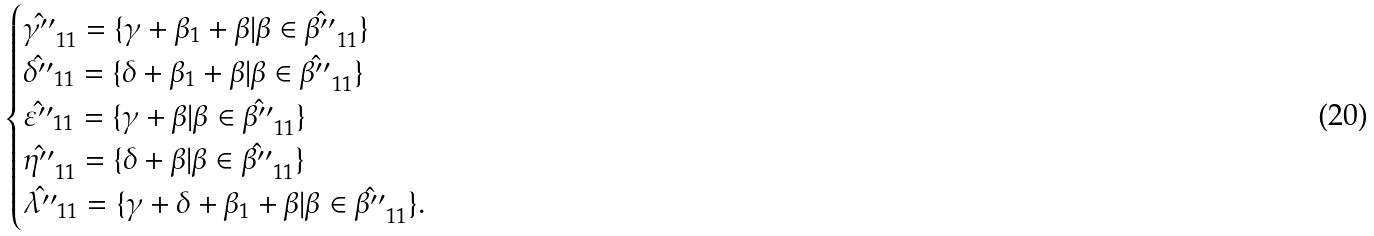Convert formula to latex. <formula><loc_0><loc_0><loc_500><loc_500>\begin{cases} \hat { \gamma ^ { \prime \prime } } _ { 1 1 } = \{ \gamma + \beta _ { 1 } + \beta | \beta \in \hat { \beta ^ { \prime \prime } } _ { 1 1 } \} \\ \hat { \delta ^ { \prime \prime } } _ { 1 1 } = \{ \delta + \beta _ { 1 } + \beta | \beta \in \hat { \beta ^ { \prime \prime } } _ { 1 1 } \} \\ \hat { \varepsilon ^ { \prime \prime } } _ { 1 1 } = \{ \gamma + \beta | \beta \in \hat { \beta ^ { \prime \prime } } _ { 1 1 } \} \\ \hat { \eta ^ { \prime \prime } } _ { 1 1 } = \{ \delta + \beta | \beta \in \hat { \beta ^ { \prime \prime } } _ { 1 1 } \} \\ \hat { \lambda ^ { \prime \prime } } _ { 1 1 } = \{ \gamma + \delta + \beta _ { 1 } + \beta | \beta \in \hat { \beta ^ { \prime \prime } } _ { 1 1 } \} . \\ \end{cases}</formula> 